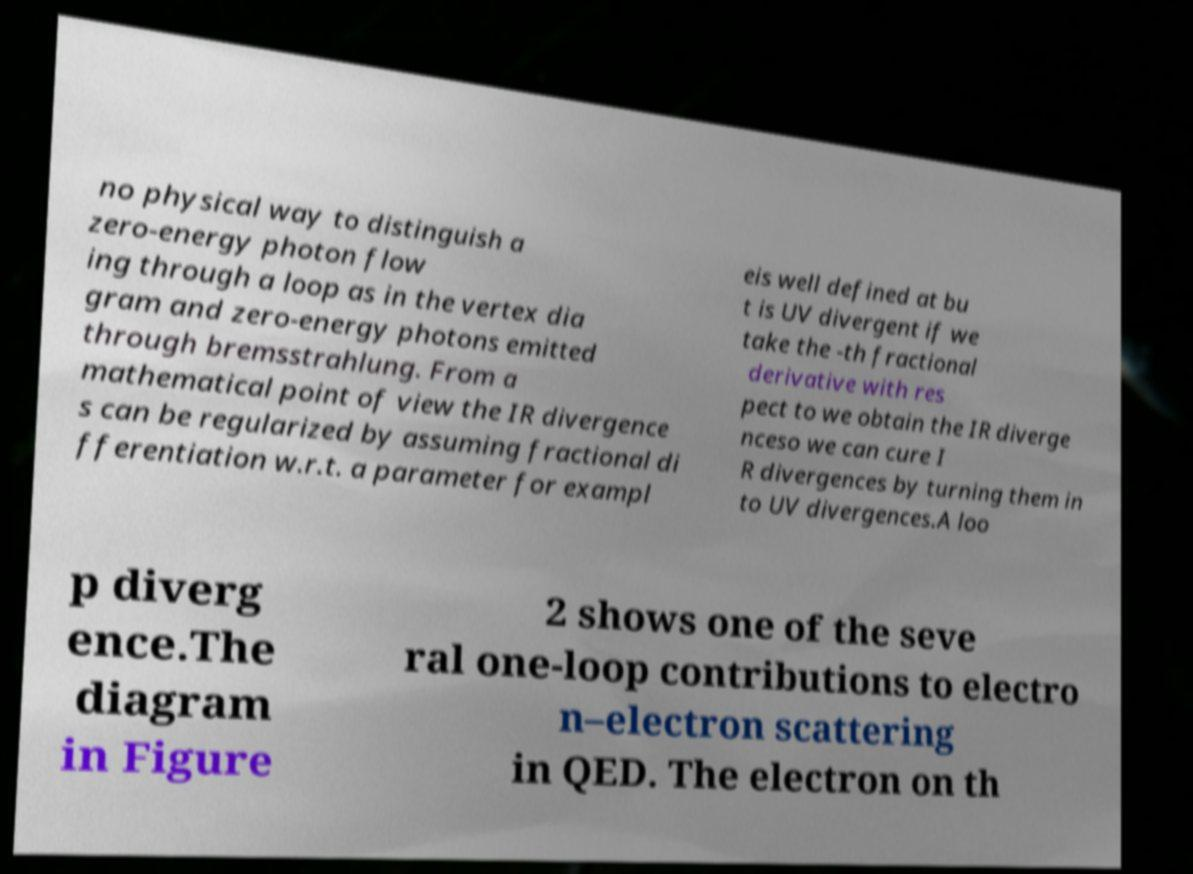Can you read and provide the text displayed in the image?This photo seems to have some interesting text. Can you extract and type it out for me? no physical way to distinguish a zero-energy photon flow ing through a loop as in the vertex dia gram and zero-energy photons emitted through bremsstrahlung. From a mathematical point of view the IR divergence s can be regularized by assuming fractional di fferentiation w.r.t. a parameter for exampl eis well defined at bu t is UV divergent if we take the -th fractional derivative with res pect to we obtain the IR diverge nceso we can cure I R divergences by turning them in to UV divergences.A loo p diverg ence.The diagram in Figure 2 shows one of the seve ral one-loop contributions to electro n–electron scattering in QED. The electron on th 